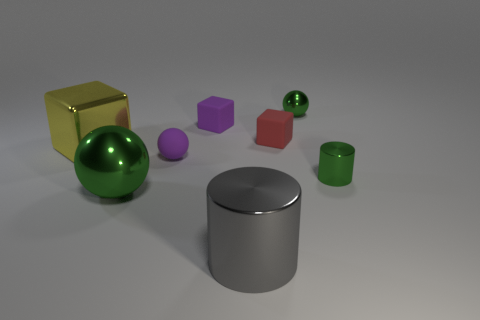Can you describe the lighting in the scene? The lighting in the scene seems to be diffuse and soft, as evidenced by the subtle shadows under the objects and the gentle reflections on the surfaces. This type of lighting typically suggests a source that is larger than the objects in the scene or possibly multiple light sources that evenly illuminate the space, reducing harsh shadows. 